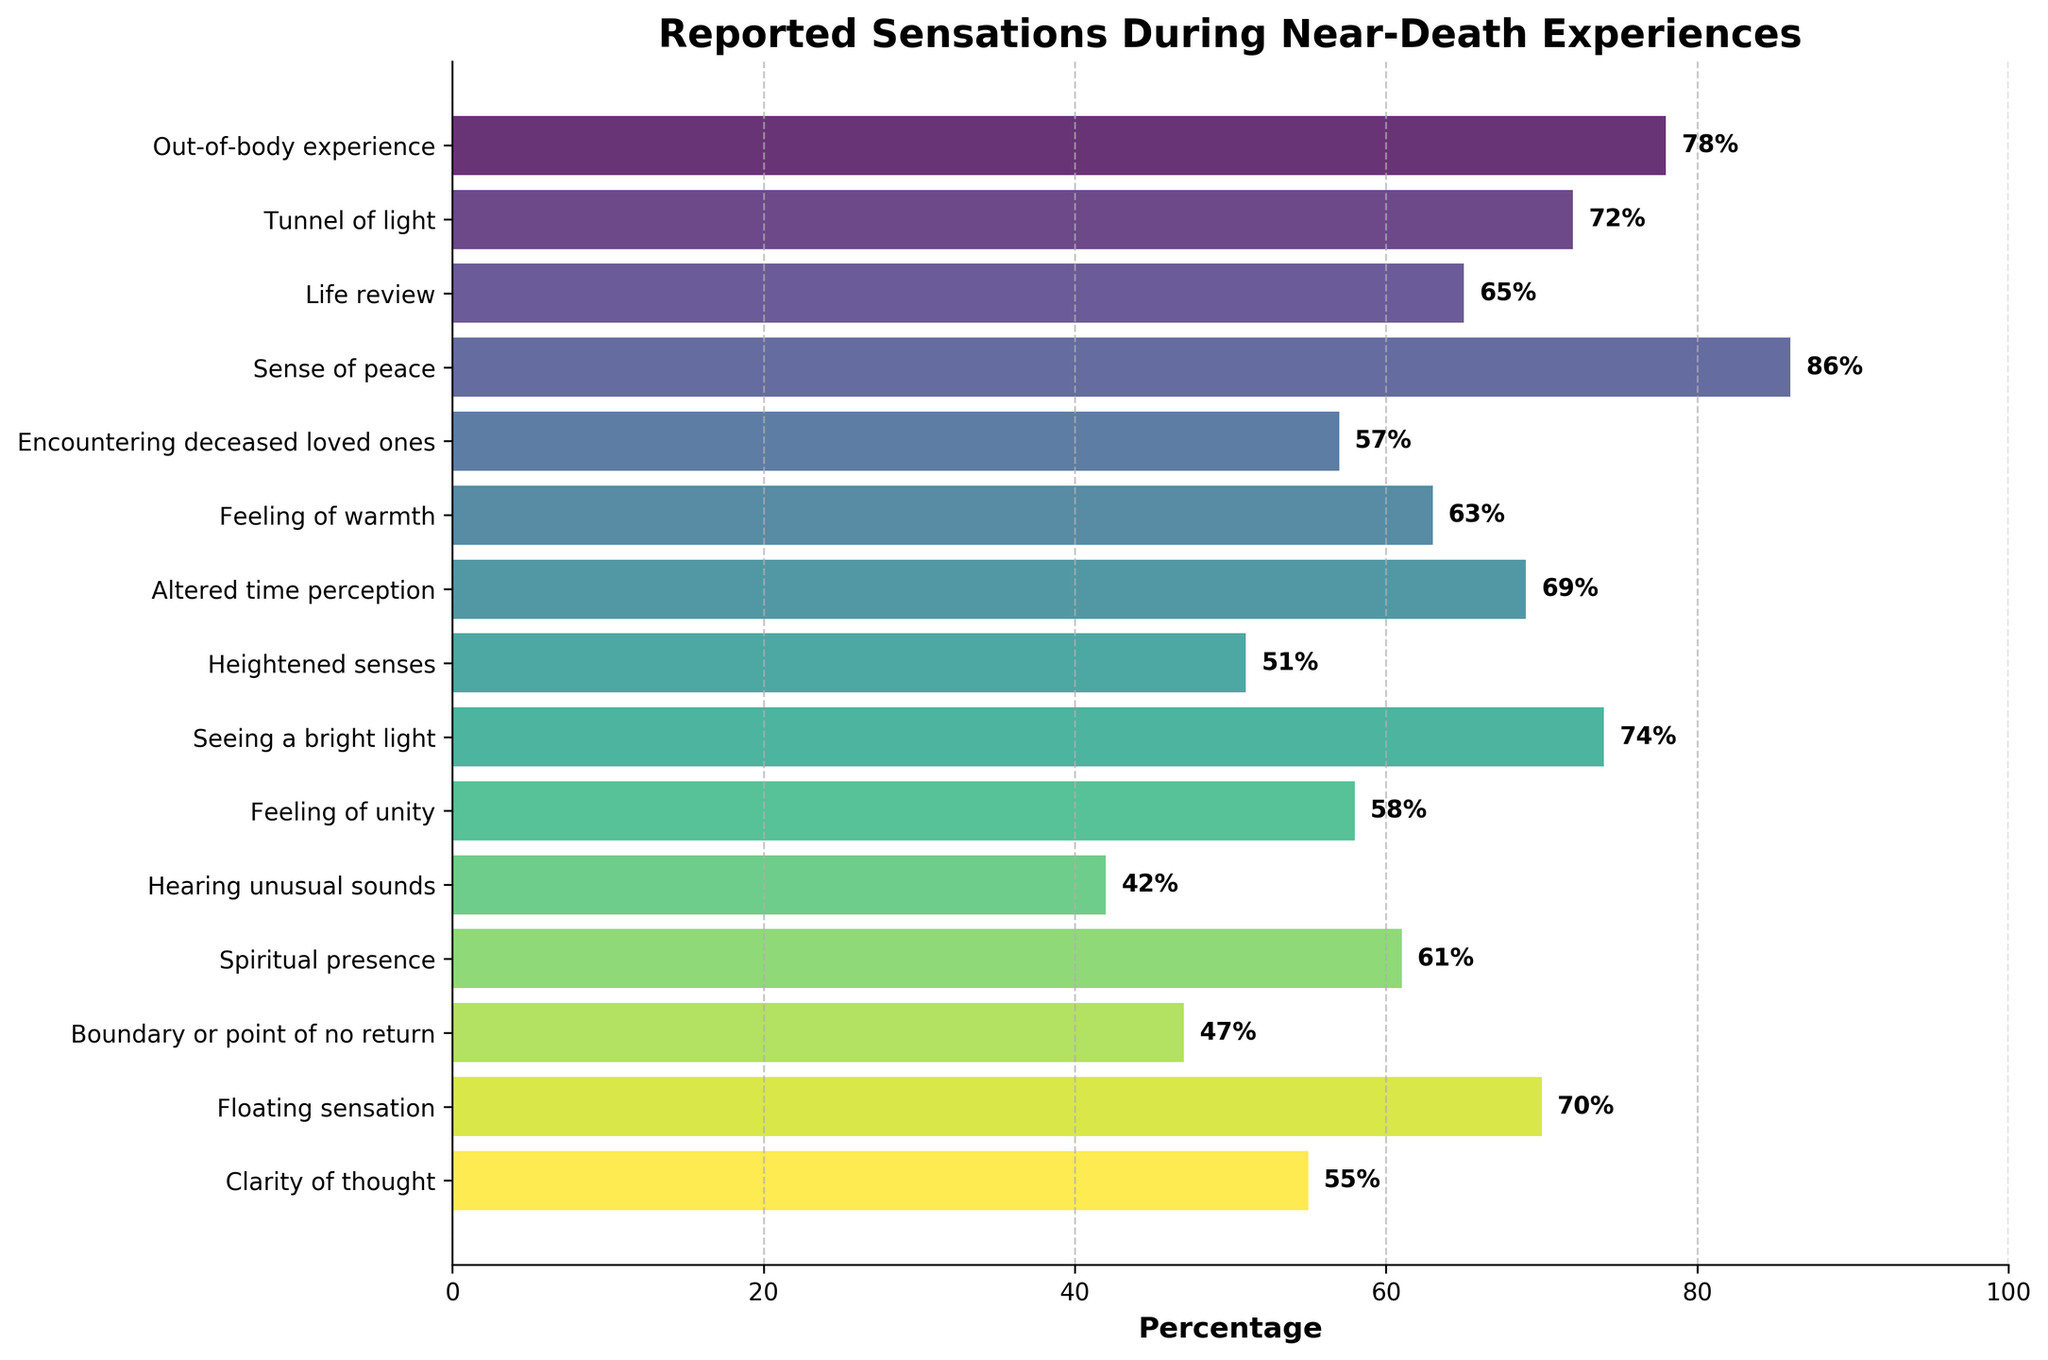What sensation has the highest reported percentage during near-death experiences? The sensation with the highest bar and number is "Sense of peace" with 86%.
Answer: Sense of peace Which two sensations have the closest reported percentages? "Feeling of warmth" with 63% and "Spiritual presence" with 61% are the closest, with only a 2% difference.
Answer: Feeling of warmth, Spiritual presence What is the total percentage when summing the reported percentages of "Out-of-body experience" and "Encountering deceased loved ones"? Add the percentages: 78% (Out-of-body experience) + 57% (Encountering deceased loved ones) = 135%.
Answer: 135% Is the percentage for "Altered time perception" higher or lower than "Tunnel of light"? "Altered time perception" is at 69% and "Tunnel of light" is at 72%. Thus, it is lower.
Answer: Lower How many sensations have a reported percentage higher than 70%? The sensations above 70% are "Out-of-body experience" (78%), "Tunnel of light" (72%), "Seeing a bright light" (74%), and "Sense of peace" (86%). That makes 4 sensations.
Answer: 4 What percentage more does "Sense of peace" have compared to "Boundary or point of no return"? "Sense of peace" has 86%, and "Boundary or point of no return" has 47%. The difference is 86% - 47% = 39%.
Answer: 39% Which sensation has the longest bar visually on the chart? The longest bar visually corresponds to "Sense of peace" at 86%.
Answer: Sense of peace If you average the reported percentages of "Clarity of thought," "Floating sensation," and "Hearing unusual sounds," what is the result? Add the percentages: 55% (Clarity of thought) + 70% (Floating sensation) + 42% (Hearing unusual sounds) = 167%. Then divide by 3: 167% / 3 ≈ 55.67%.
Answer: 55.67% 